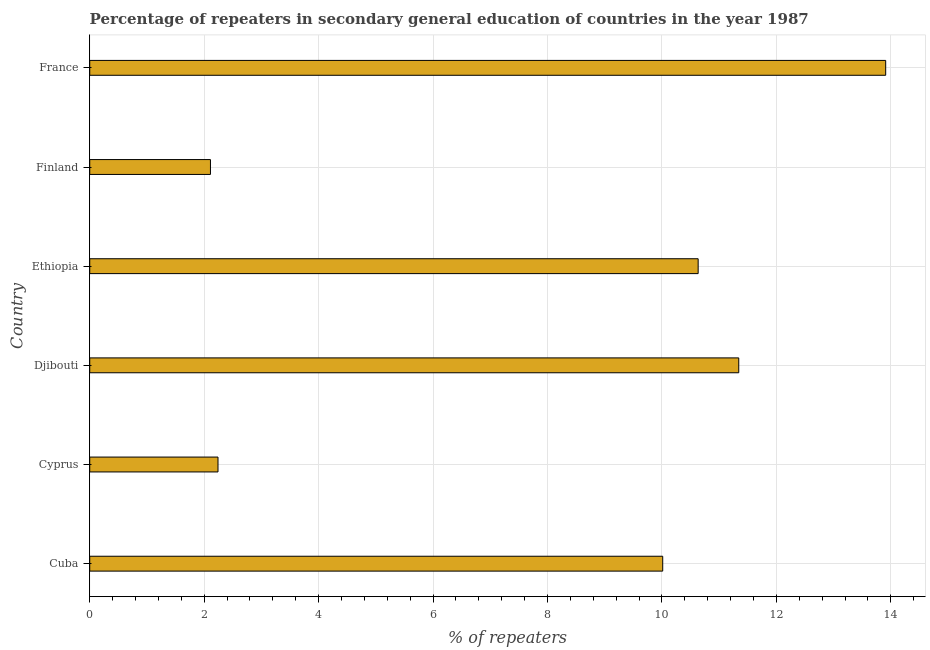Does the graph contain grids?
Provide a succinct answer. Yes. What is the title of the graph?
Your answer should be compact. Percentage of repeaters in secondary general education of countries in the year 1987. What is the label or title of the X-axis?
Make the answer very short. % of repeaters. What is the label or title of the Y-axis?
Ensure brevity in your answer.  Country. What is the percentage of repeaters in France?
Your answer should be compact. 13.91. Across all countries, what is the maximum percentage of repeaters?
Give a very brief answer. 13.91. Across all countries, what is the minimum percentage of repeaters?
Your answer should be very brief. 2.11. In which country was the percentage of repeaters minimum?
Your answer should be compact. Finland. What is the sum of the percentage of repeaters?
Provide a short and direct response. 50.25. What is the difference between the percentage of repeaters in Cuba and France?
Your response must be concise. -3.9. What is the average percentage of repeaters per country?
Your answer should be compact. 8.38. What is the median percentage of repeaters?
Provide a short and direct response. 10.32. What is the ratio of the percentage of repeaters in Cyprus to that in Djibouti?
Provide a succinct answer. 0.2. Is the difference between the percentage of repeaters in Finland and France greater than the difference between any two countries?
Give a very brief answer. Yes. What is the difference between the highest and the second highest percentage of repeaters?
Offer a terse response. 2.57. Is the sum of the percentage of repeaters in Ethiopia and France greater than the maximum percentage of repeaters across all countries?
Make the answer very short. Yes. In how many countries, is the percentage of repeaters greater than the average percentage of repeaters taken over all countries?
Ensure brevity in your answer.  4. How many countries are there in the graph?
Provide a short and direct response. 6. What is the difference between two consecutive major ticks on the X-axis?
Keep it short and to the point. 2. What is the % of repeaters of Cuba?
Keep it short and to the point. 10.01. What is the % of repeaters of Cyprus?
Your answer should be very brief. 2.24. What is the % of repeaters of Djibouti?
Your answer should be very brief. 11.34. What is the % of repeaters of Ethiopia?
Provide a short and direct response. 10.63. What is the % of repeaters of Finland?
Give a very brief answer. 2.11. What is the % of repeaters of France?
Provide a succinct answer. 13.91. What is the difference between the % of repeaters in Cuba and Cyprus?
Your answer should be compact. 7.77. What is the difference between the % of repeaters in Cuba and Djibouti?
Your answer should be compact. -1.33. What is the difference between the % of repeaters in Cuba and Ethiopia?
Offer a very short reply. -0.62. What is the difference between the % of repeaters in Cuba and Finland?
Ensure brevity in your answer.  7.9. What is the difference between the % of repeaters in Cuba and France?
Make the answer very short. -3.9. What is the difference between the % of repeaters in Cyprus and Djibouti?
Your answer should be very brief. -9.1. What is the difference between the % of repeaters in Cyprus and Ethiopia?
Make the answer very short. -8.39. What is the difference between the % of repeaters in Cyprus and Finland?
Your answer should be compact. 0.13. What is the difference between the % of repeaters in Cyprus and France?
Provide a succinct answer. -11.67. What is the difference between the % of repeaters in Djibouti and Ethiopia?
Keep it short and to the point. 0.71. What is the difference between the % of repeaters in Djibouti and Finland?
Provide a succinct answer. 9.23. What is the difference between the % of repeaters in Djibouti and France?
Your answer should be compact. -2.57. What is the difference between the % of repeaters in Ethiopia and Finland?
Your response must be concise. 8.52. What is the difference between the % of repeaters in Ethiopia and France?
Offer a very short reply. -3.28. What is the difference between the % of repeaters in Finland and France?
Your answer should be very brief. -11.8. What is the ratio of the % of repeaters in Cuba to that in Cyprus?
Offer a terse response. 4.47. What is the ratio of the % of repeaters in Cuba to that in Djibouti?
Make the answer very short. 0.88. What is the ratio of the % of repeaters in Cuba to that in Ethiopia?
Ensure brevity in your answer.  0.94. What is the ratio of the % of repeaters in Cuba to that in Finland?
Ensure brevity in your answer.  4.75. What is the ratio of the % of repeaters in Cuba to that in France?
Your answer should be compact. 0.72. What is the ratio of the % of repeaters in Cyprus to that in Djibouti?
Offer a terse response. 0.2. What is the ratio of the % of repeaters in Cyprus to that in Ethiopia?
Provide a short and direct response. 0.21. What is the ratio of the % of repeaters in Cyprus to that in Finland?
Give a very brief answer. 1.06. What is the ratio of the % of repeaters in Cyprus to that in France?
Offer a very short reply. 0.16. What is the ratio of the % of repeaters in Djibouti to that in Ethiopia?
Keep it short and to the point. 1.07. What is the ratio of the % of repeaters in Djibouti to that in Finland?
Ensure brevity in your answer.  5.38. What is the ratio of the % of repeaters in Djibouti to that in France?
Offer a terse response. 0.81. What is the ratio of the % of repeaters in Ethiopia to that in Finland?
Offer a terse response. 5.04. What is the ratio of the % of repeaters in Ethiopia to that in France?
Make the answer very short. 0.76. What is the ratio of the % of repeaters in Finland to that in France?
Keep it short and to the point. 0.15. 